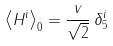<formula> <loc_0><loc_0><loc_500><loc_500>\left \langle H ^ { i } \right \rangle _ { 0 } = \frac { v } { \sqrt { 2 } } \, \delta _ { 5 } ^ { i }</formula> 